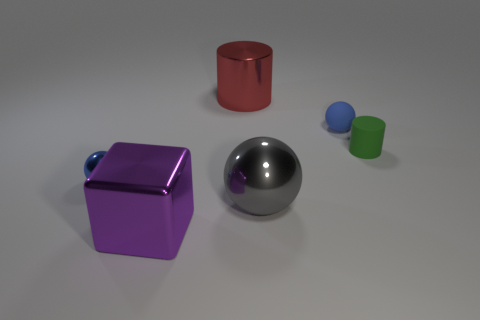What size is the shiny thing that is the same color as the tiny matte sphere?
Keep it short and to the point. Small. Does the large object to the left of the large metallic cylinder have the same color as the shiny sphere behind the large gray object?
Make the answer very short. No. How many other objects are the same material as the tiny cylinder?
Offer a terse response. 1. Are any tiny blue metallic cubes visible?
Keep it short and to the point. No. Does the cylinder to the right of the small blue rubber sphere have the same material as the big sphere?
Offer a terse response. No. There is a green thing that is the same shape as the big red thing; what is its material?
Offer a terse response. Rubber. What is the material of the other object that is the same color as the tiny shiny object?
Provide a short and direct response. Rubber. Is the number of brown rubber balls less than the number of big purple cubes?
Provide a short and direct response. Yes. There is a metallic ball that is on the left side of the big metallic ball; is it the same color as the metal cylinder?
Offer a very short reply. No. The large ball that is the same material as the large block is what color?
Make the answer very short. Gray. 